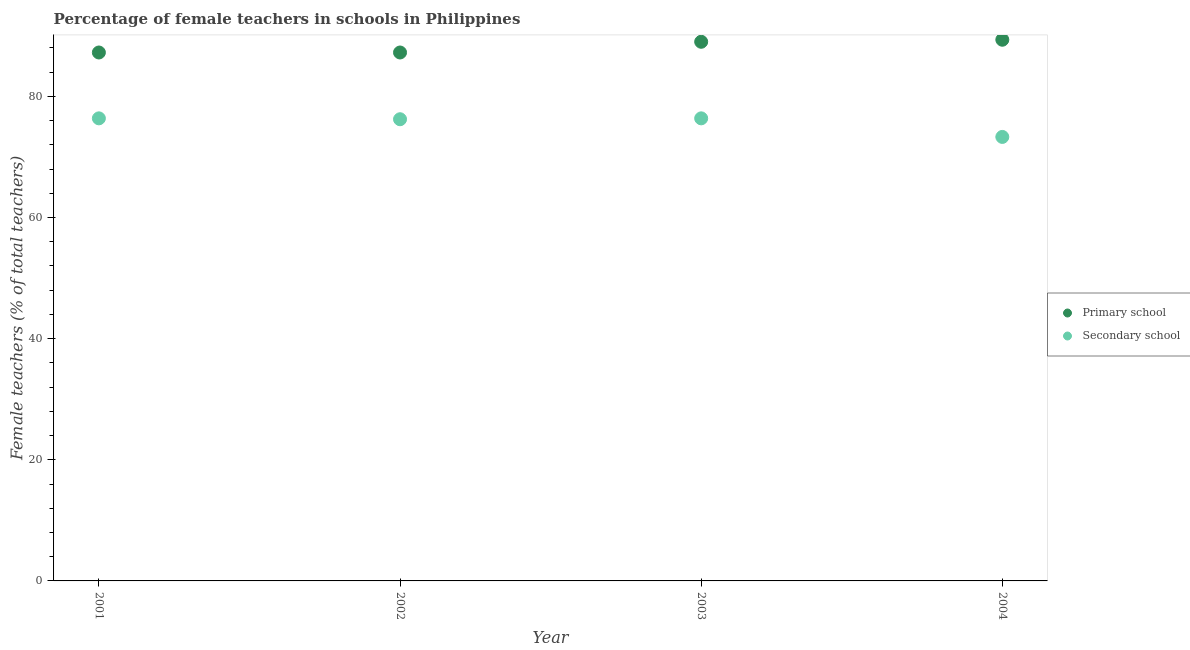What is the percentage of female teachers in primary schools in 2001?
Your answer should be very brief. 87.25. Across all years, what is the maximum percentage of female teachers in primary schools?
Offer a very short reply. 89.36. Across all years, what is the minimum percentage of female teachers in primary schools?
Give a very brief answer. 87.25. In which year was the percentage of female teachers in secondary schools maximum?
Offer a very short reply. 2003. In which year was the percentage of female teachers in secondary schools minimum?
Your response must be concise. 2004. What is the total percentage of female teachers in primary schools in the graph?
Offer a terse response. 352.88. What is the difference between the percentage of female teachers in primary schools in 2002 and that in 2003?
Provide a succinct answer. -1.77. What is the difference between the percentage of female teachers in secondary schools in 2003 and the percentage of female teachers in primary schools in 2001?
Your answer should be very brief. -10.87. What is the average percentage of female teachers in secondary schools per year?
Give a very brief answer. 75.57. In the year 2001, what is the difference between the percentage of female teachers in secondary schools and percentage of female teachers in primary schools?
Your answer should be compact. -10.87. What is the ratio of the percentage of female teachers in primary schools in 2002 to that in 2003?
Offer a terse response. 0.98. What is the difference between the highest and the second highest percentage of female teachers in secondary schools?
Offer a very short reply. 0. What is the difference between the highest and the lowest percentage of female teachers in primary schools?
Make the answer very short. 2.11. Is the sum of the percentage of female teachers in secondary schools in 2003 and 2004 greater than the maximum percentage of female teachers in primary schools across all years?
Give a very brief answer. Yes. Does the percentage of female teachers in secondary schools monotonically increase over the years?
Give a very brief answer. No. Is the percentage of female teachers in secondary schools strictly greater than the percentage of female teachers in primary schools over the years?
Give a very brief answer. No. How many dotlines are there?
Keep it short and to the point. 2. Does the graph contain any zero values?
Keep it short and to the point. No. How are the legend labels stacked?
Offer a very short reply. Vertical. What is the title of the graph?
Your response must be concise. Percentage of female teachers in schools in Philippines. Does "Merchandise exports" appear as one of the legend labels in the graph?
Give a very brief answer. No. What is the label or title of the X-axis?
Ensure brevity in your answer.  Year. What is the label or title of the Y-axis?
Your answer should be very brief. Female teachers (% of total teachers). What is the Female teachers (% of total teachers) of Primary school in 2001?
Offer a terse response. 87.25. What is the Female teachers (% of total teachers) of Secondary school in 2001?
Give a very brief answer. 76.38. What is the Female teachers (% of total teachers) of Primary school in 2002?
Provide a succinct answer. 87.25. What is the Female teachers (% of total teachers) in Secondary school in 2002?
Offer a very short reply. 76.23. What is the Female teachers (% of total teachers) of Primary school in 2003?
Provide a succinct answer. 89.02. What is the Female teachers (% of total teachers) in Secondary school in 2003?
Provide a short and direct response. 76.38. What is the Female teachers (% of total teachers) in Primary school in 2004?
Provide a succinct answer. 89.36. What is the Female teachers (% of total teachers) in Secondary school in 2004?
Provide a succinct answer. 73.31. Across all years, what is the maximum Female teachers (% of total teachers) in Primary school?
Ensure brevity in your answer.  89.36. Across all years, what is the maximum Female teachers (% of total teachers) in Secondary school?
Keep it short and to the point. 76.38. Across all years, what is the minimum Female teachers (% of total teachers) of Primary school?
Provide a succinct answer. 87.25. Across all years, what is the minimum Female teachers (% of total teachers) in Secondary school?
Your response must be concise. 73.31. What is the total Female teachers (% of total teachers) of Primary school in the graph?
Make the answer very short. 352.88. What is the total Female teachers (% of total teachers) in Secondary school in the graph?
Offer a very short reply. 302.3. What is the difference between the Female teachers (% of total teachers) of Secondary school in 2001 and that in 2002?
Make the answer very short. 0.15. What is the difference between the Female teachers (% of total teachers) in Primary school in 2001 and that in 2003?
Make the answer very short. -1.77. What is the difference between the Female teachers (% of total teachers) of Secondary school in 2001 and that in 2003?
Give a very brief answer. -0. What is the difference between the Female teachers (% of total teachers) in Primary school in 2001 and that in 2004?
Make the answer very short. -2.11. What is the difference between the Female teachers (% of total teachers) of Secondary school in 2001 and that in 2004?
Keep it short and to the point. 3.07. What is the difference between the Female teachers (% of total teachers) of Primary school in 2002 and that in 2003?
Ensure brevity in your answer.  -1.77. What is the difference between the Female teachers (% of total teachers) of Secondary school in 2002 and that in 2003?
Your answer should be very brief. -0.15. What is the difference between the Female teachers (% of total teachers) in Primary school in 2002 and that in 2004?
Your response must be concise. -2.11. What is the difference between the Female teachers (% of total teachers) of Secondary school in 2002 and that in 2004?
Your answer should be very brief. 2.92. What is the difference between the Female teachers (% of total teachers) of Primary school in 2003 and that in 2004?
Keep it short and to the point. -0.34. What is the difference between the Female teachers (% of total teachers) of Secondary school in 2003 and that in 2004?
Provide a succinct answer. 3.07. What is the difference between the Female teachers (% of total teachers) of Primary school in 2001 and the Female teachers (% of total teachers) of Secondary school in 2002?
Ensure brevity in your answer.  11.02. What is the difference between the Female teachers (% of total teachers) in Primary school in 2001 and the Female teachers (% of total teachers) in Secondary school in 2003?
Your response must be concise. 10.87. What is the difference between the Female teachers (% of total teachers) of Primary school in 2001 and the Female teachers (% of total teachers) of Secondary school in 2004?
Offer a very short reply. 13.94. What is the difference between the Female teachers (% of total teachers) in Primary school in 2002 and the Female teachers (% of total teachers) in Secondary school in 2003?
Your answer should be compact. 10.87. What is the difference between the Female teachers (% of total teachers) in Primary school in 2002 and the Female teachers (% of total teachers) in Secondary school in 2004?
Your answer should be compact. 13.94. What is the difference between the Female teachers (% of total teachers) of Primary school in 2003 and the Female teachers (% of total teachers) of Secondary school in 2004?
Provide a succinct answer. 15.71. What is the average Female teachers (% of total teachers) in Primary school per year?
Provide a short and direct response. 88.22. What is the average Female teachers (% of total teachers) of Secondary school per year?
Keep it short and to the point. 75.57. In the year 2001, what is the difference between the Female teachers (% of total teachers) in Primary school and Female teachers (% of total teachers) in Secondary school?
Offer a very short reply. 10.87. In the year 2002, what is the difference between the Female teachers (% of total teachers) of Primary school and Female teachers (% of total teachers) of Secondary school?
Your answer should be compact. 11.02. In the year 2003, what is the difference between the Female teachers (% of total teachers) of Primary school and Female teachers (% of total teachers) of Secondary school?
Your response must be concise. 12.64. In the year 2004, what is the difference between the Female teachers (% of total teachers) in Primary school and Female teachers (% of total teachers) in Secondary school?
Offer a terse response. 16.05. What is the ratio of the Female teachers (% of total teachers) in Primary school in 2001 to that in 2002?
Offer a terse response. 1. What is the ratio of the Female teachers (% of total teachers) in Primary school in 2001 to that in 2003?
Keep it short and to the point. 0.98. What is the ratio of the Female teachers (% of total teachers) in Secondary school in 2001 to that in 2003?
Offer a terse response. 1. What is the ratio of the Female teachers (% of total teachers) of Primary school in 2001 to that in 2004?
Your answer should be compact. 0.98. What is the ratio of the Female teachers (% of total teachers) in Secondary school in 2001 to that in 2004?
Offer a terse response. 1.04. What is the ratio of the Female teachers (% of total teachers) of Primary school in 2002 to that in 2003?
Ensure brevity in your answer.  0.98. What is the ratio of the Female teachers (% of total teachers) in Primary school in 2002 to that in 2004?
Provide a succinct answer. 0.98. What is the ratio of the Female teachers (% of total teachers) of Secondary school in 2002 to that in 2004?
Your response must be concise. 1.04. What is the ratio of the Female teachers (% of total teachers) of Primary school in 2003 to that in 2004?
Provide a succinct answer. 1. What is the ratio of the Female teachers (% of total teachers) of Secondary school in 2003 to that in 2004?
Keep it short and to the point. 1.04. What is the difference between the highest and the second highest Female teachers (% of total teachers) of Primary school?
Your answer should be very brief. 0.34. What is the difference between the highest and the second highest Female teachers (% of total teachers) in Secondary school?
Provide a short and direct response. 0. What is the difference between the highest and the lowest Female teachers (% of total teachers) of Primary school?
Offer a terse response. 2.11. What is the difference between the highest and the lowest Female teachers (% of total teachers) in Secondary school?
Provide a short and direct response. 3.07. 